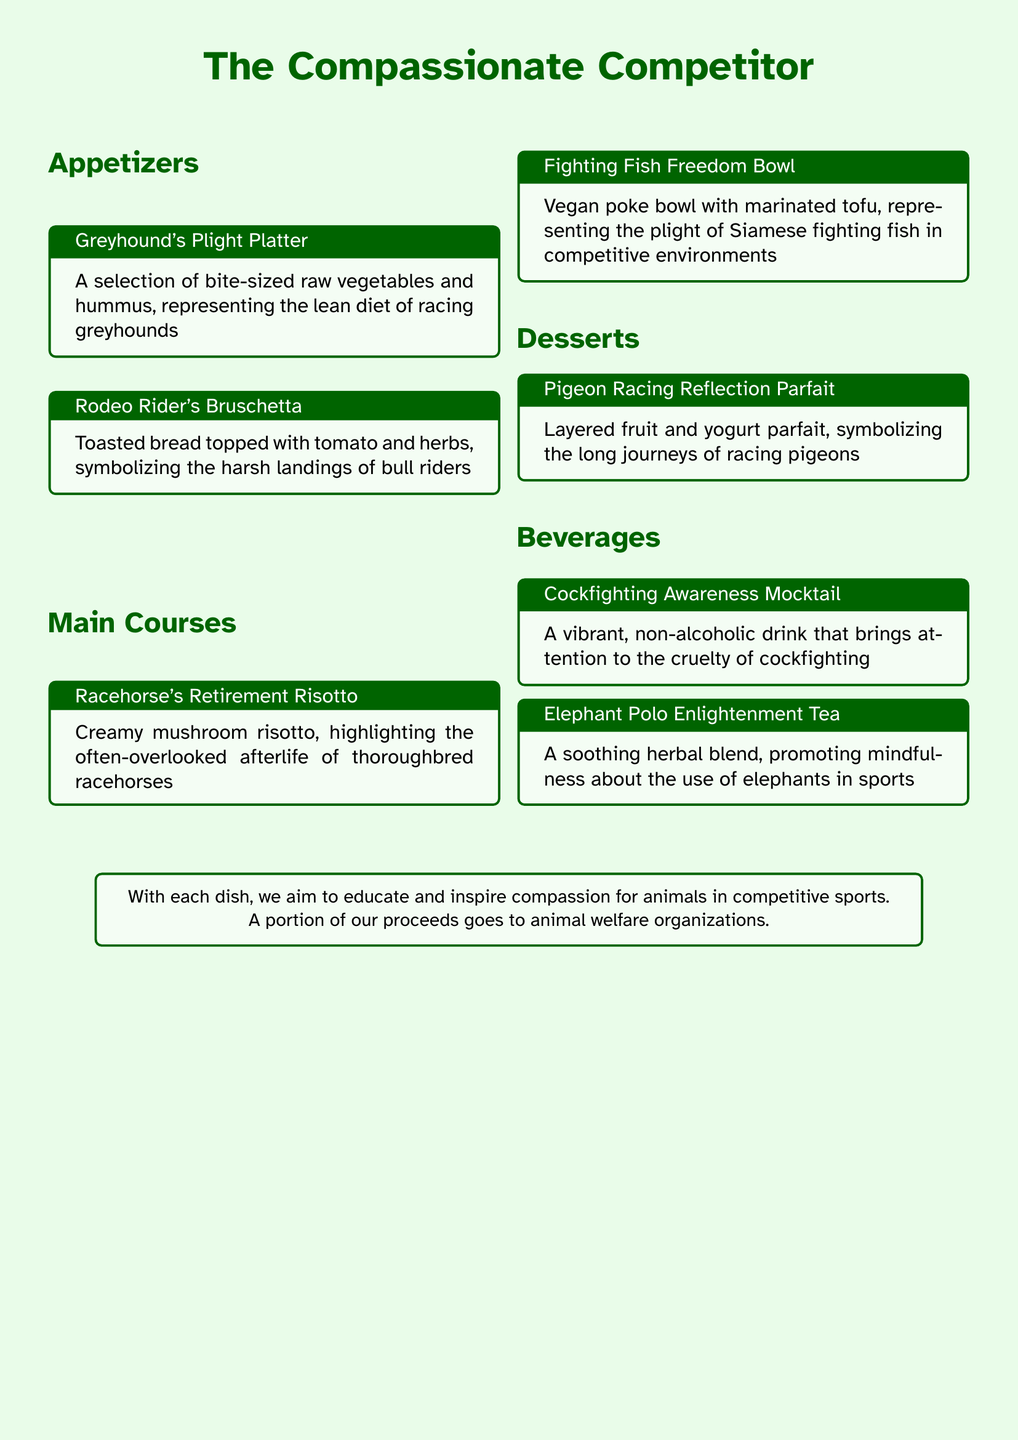What is the title of the menu? The title is prominently displayed at the top of the document, stating the theme and purpose of the menu.
Answer: The Compassionate Competitor What type of tea is offered? The beverages section includes a specific type of herbal tea aimed at raising awareness about elephants in sports.
Answer: Elephant Polo Enlightenment Tea What dish represents the racing greyhounds? The appetizers section lists a platter specifically highlighting the diet of racing greyhounds.
Answer: Greyhound's Plight Platter What is included in the Fighting Fish Freedom Bowl? The main courses section describes a vegan bowl which symbolizes the plight of Siamese fighting fish.
Answer: Marinated tofu How does the menu aim to promote awareness? The final note in the document indicates the overall purpose and charitable aspect of the menu.
Answer: Educate and inspire compassion What dessert symbolizes racing pigeons? The desserts section features a parfait that represents the long journeys of racing pigeons.
Answer: Pigeon Racing Reflection Parfait Which appetizer symbolizes bull riders? The menu specifically highlights a dish that reflects the experience of bull riders in competitive environments.
Answer: Rodeo Rider's Bruschetta How many courses are listed on the menu? By counting the sections in the document, we can determine the number of distinct courses listed.
Answer: Three courses What type of drink highlights cockfighting? The beverages section has a specific mocktail designed to bring attention to the cruelty of a certain sport.
Answer: Cockfighting Awareness Mocktail 